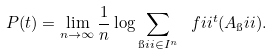<formula> <loc_0><loc_0><loc_500><loc_500>P ( t ) = \lim _ { n \to \infty } \frac { 1 } { n } \log \sum _ { \i i i \in I ^ { n } } \ f i i ^ { t } ( A _ { \i } i i ) .</formula> 